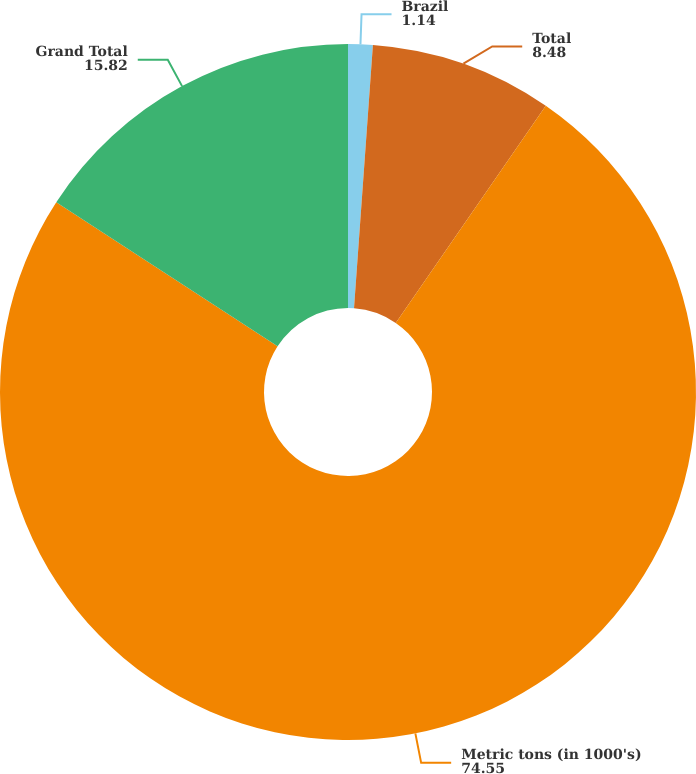Convert chart. <chart><loc_0><loc_0><loc_500><loc_500><pie_chart><fcel>Brazil<fcel>Total<fcel>Metric tons (in 1000's)<fcel>Grand Total<nl><fcel>1.14%<fcel>8.48%<fcel>74.55%<fcel>15.82%<nl></chart> 